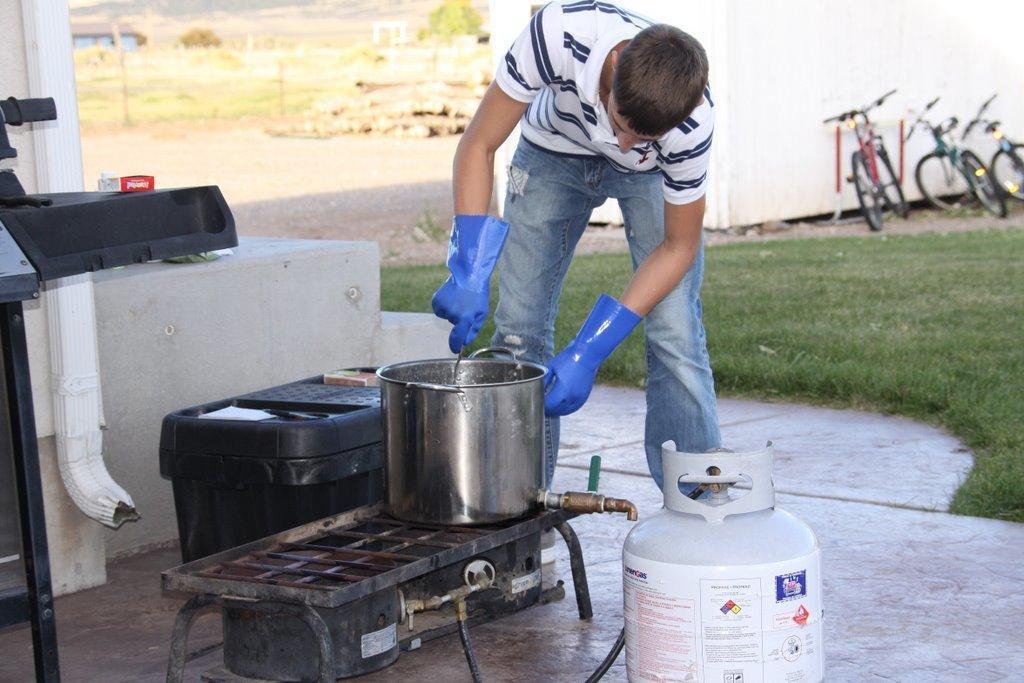Could you give a brief overview of what you see in this image? In this image I can see a man is standing and I can see he is wearing blue colour gloves. In the front of him I can see a white colour cylinder, a black pipe, a gas stove and a black colour thing. On this gas stove I can see a steel utensil. On the left side of this image I can see a black colour thing and on the right side of this image I can see grass ground and three bicycles. In the background I can see few trees. 